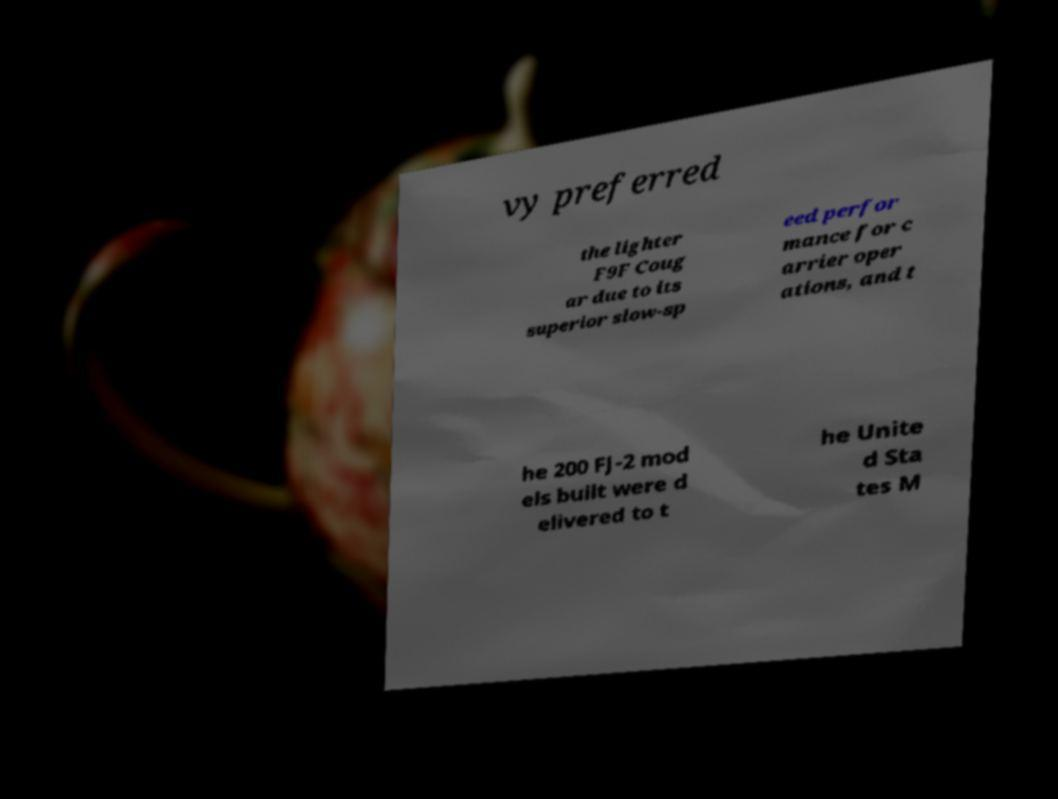Can you accurately transcribe the text from the provided image for me? vy preferred the lighter F9F Coug ar due to its superior slow-sp eed perfor mance for c arrier oper ations, and t he 200 FJ-2 mod els built were d elivered to t he Unite d Sta tes M 